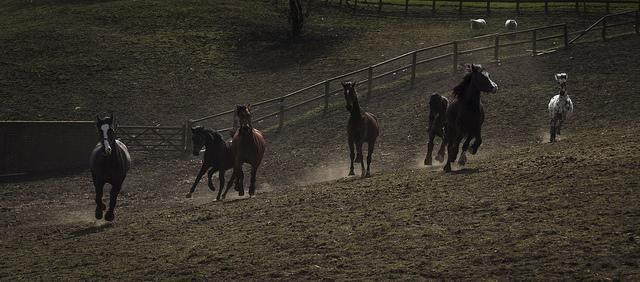What is used to keep the horses in one area? fence 